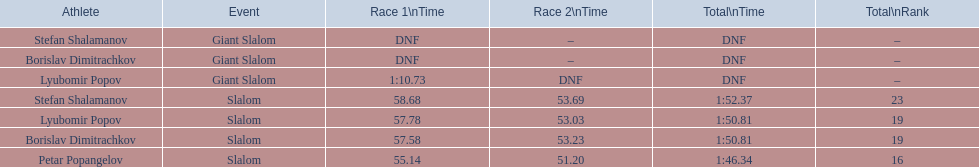In the slalom overall, who was at the bottom of the rankings? Stefan Shalamanov. 